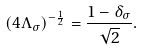Convert formula to latex. <formula><loc_0><loc_0><loc_500><loc_500>( 4 \Lambda _ { \sigma } ) ^ { - \frac { 1 } { 2 } } = \frac { 1 - \delta _ { \sigma } } { \sqrt { 2 } } .</formula> 